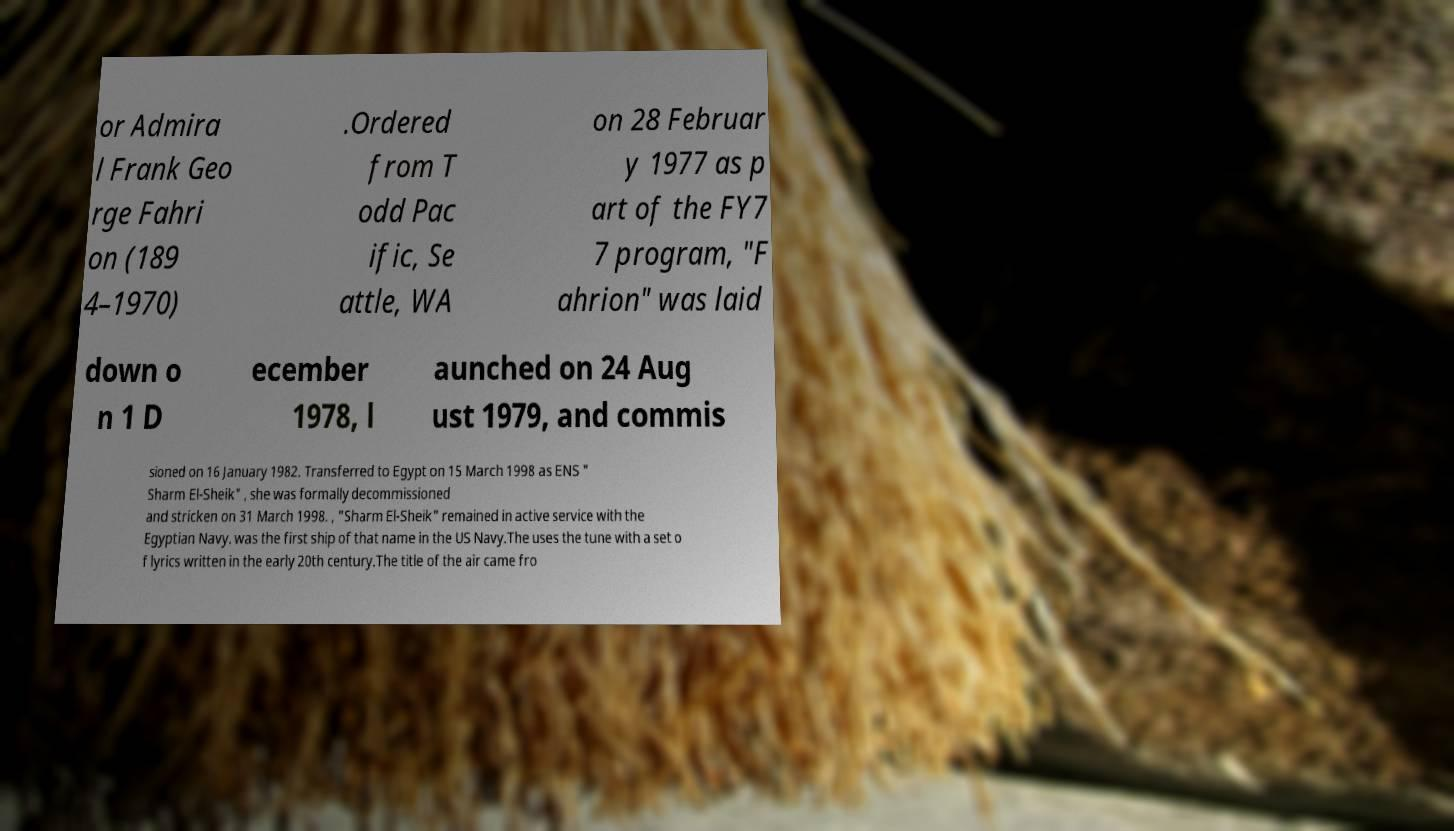Please read and relay the text visible in this image. What does it say? or Admira l Frank Geo rge Fahri on (189 4–1970) .Ordered from T odd Pac ific, Se attle, WA on 28 Februar y 1977 as p art of the FY7 7 program, "F ahrion" was laid down o n 1 D ecember 1978, l aunched on 24 Aug ust 1979, and commis sioned on 16 January 1982. Transferred to Egypt on 15 March 1998 as ENS " Sharm El-Sheik" , she was formally decommissioned and stricken on 31 March 1998. , "Sharm El-Sheik" remained in active service with the Egyptian Navy. was the first ship of that name in the US Navy.The uses the tune with a set o f lyrics written in the early 20th century.The title of the air came fro 